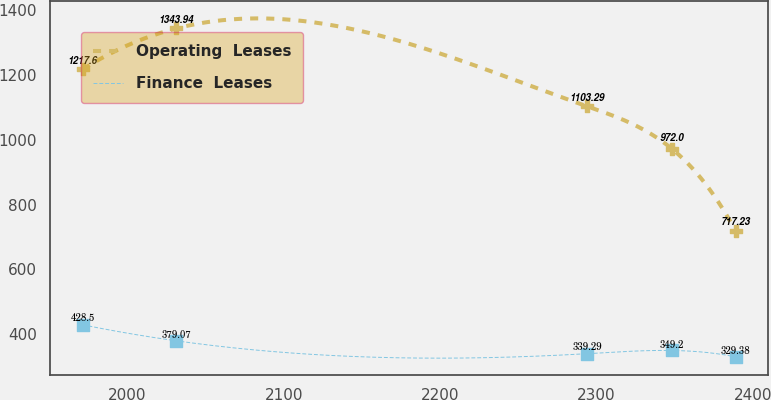Convert chart. <chart><loc_0><loc_0><loc_500><loc_500><line_chart><ecel><fcel>Operating  Leases<fcel>Finance  Leases<nl><fcel>1971.56<fcel>1217.6<fcel>428.5<nl><fcel>2031.36<fcel>1343.94<fcel>379.07<nl><fcel>2293.94<fcel>1103.29<fcel>339.29<nl><fcel>2348.2<fcel>972<fcel>349.2<nl><fcel>2389<fcel>717.23<fcel>329.38<nl></chart> 